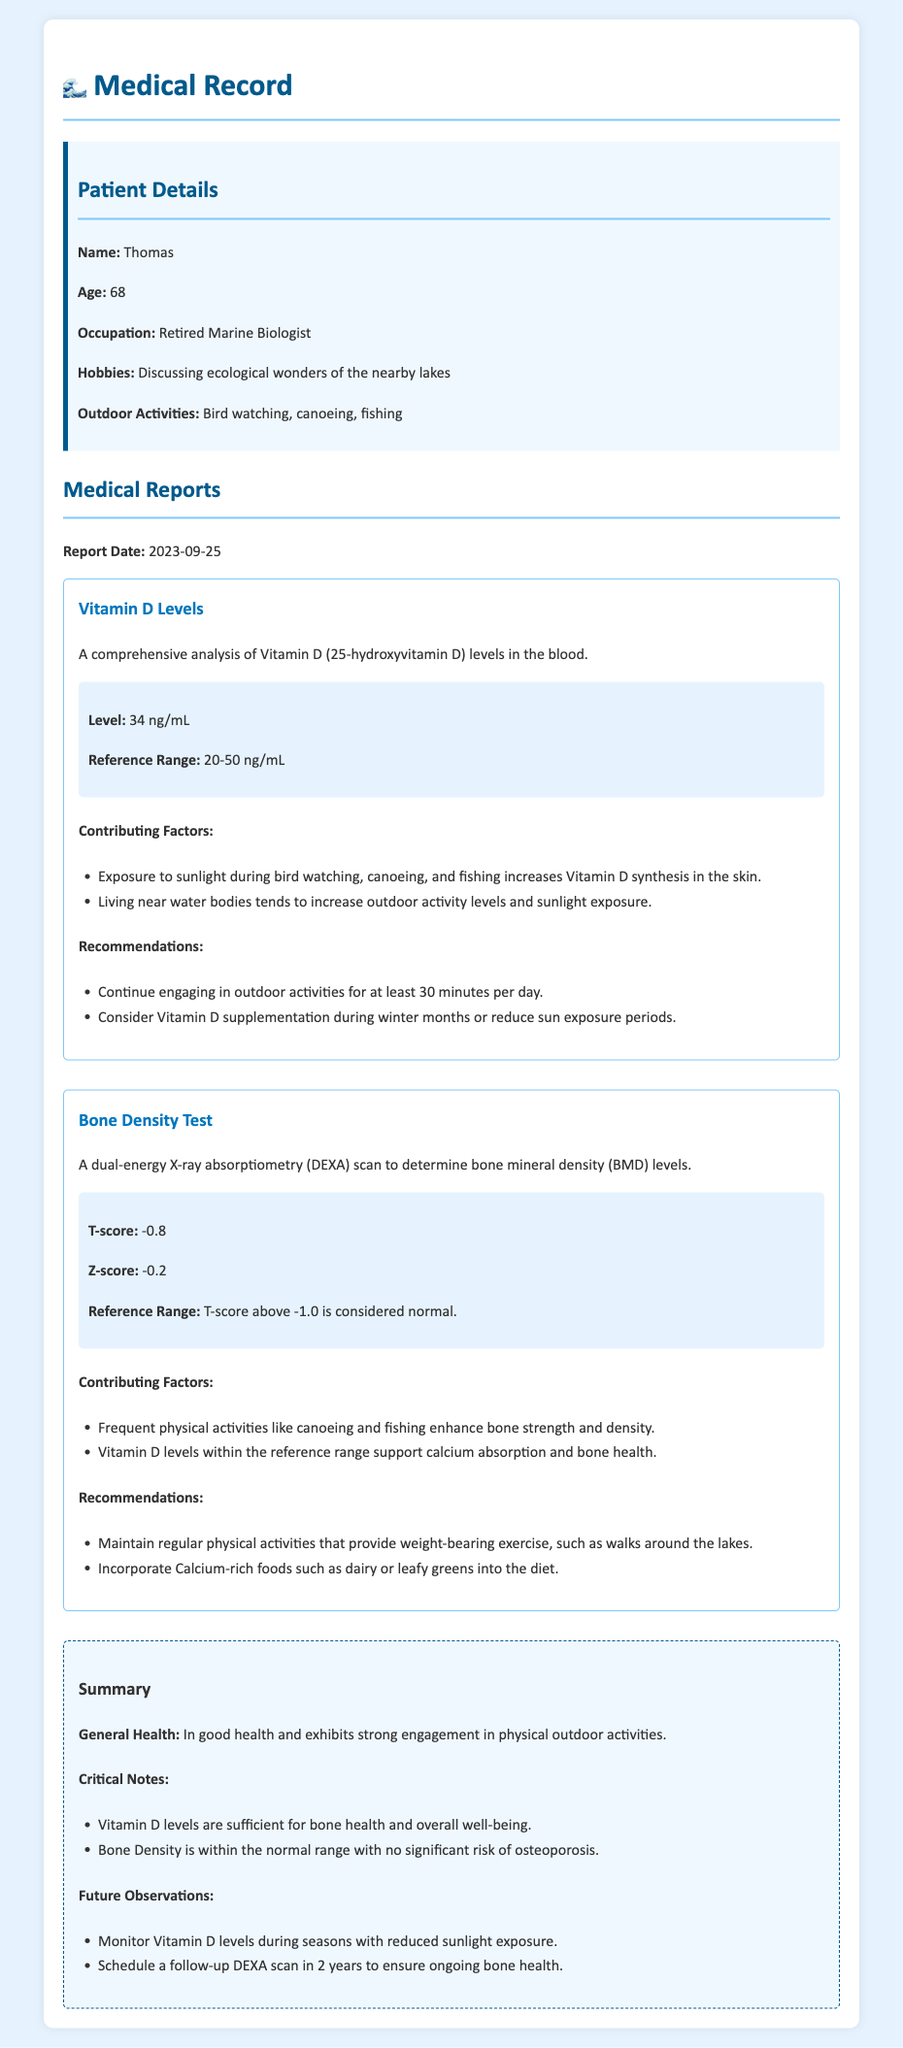What is Thomas's age? The document states Thomas's age in the patient details section, which is 68.
Answer: 68 What is the Vitamin D level? The Vitamin D level is found in the test results section, which reports it as 34 ng/mL.
Answer: 34 ng/mL What is the T-score from the Bone Density Test? The T-score is provided in the Bone Density Test section, listed as -0.8.
Answer: -0.8 What outdoor activities does Thomas engage in? The patient info section lists Thomas's outdoor activities, specifically bird watching, canoeing, and fishing.
Answer: Bird watching, canoeing, fishing What are the recommendations for Vitamin D supplementation? The recommendations for Vitamin D are noted in the Vitamin D section, suggesting supplementation during winter months.
Answer: During winter months Why is Thomas's Bone Density considered normal? The document states the T-score normal range is above -1.0, and Thomas's T-score is -0.8, thus considered normal.
Answer: T-score above -1.0 How often should Thomas monitor Vitamin D levels? In the summary section, it suggests monitoring Vitamin D levels during seasons with reduced sunlight exposure.
Answer: During seasons with reduced sunlight exposure What is the reason for the recommendations of weight-bearing exercises? The contributing factors in the Bone Density Test section indicate that frequent physical activities enhance bone strength and density.
Answer: Enhance bone strength and density When is Thomas's next follow-up DEXA scan scheduled? The summary section indicates that a follow-up DEXA scan is to be scheduled in 2 years.
Answer: In 2 years 